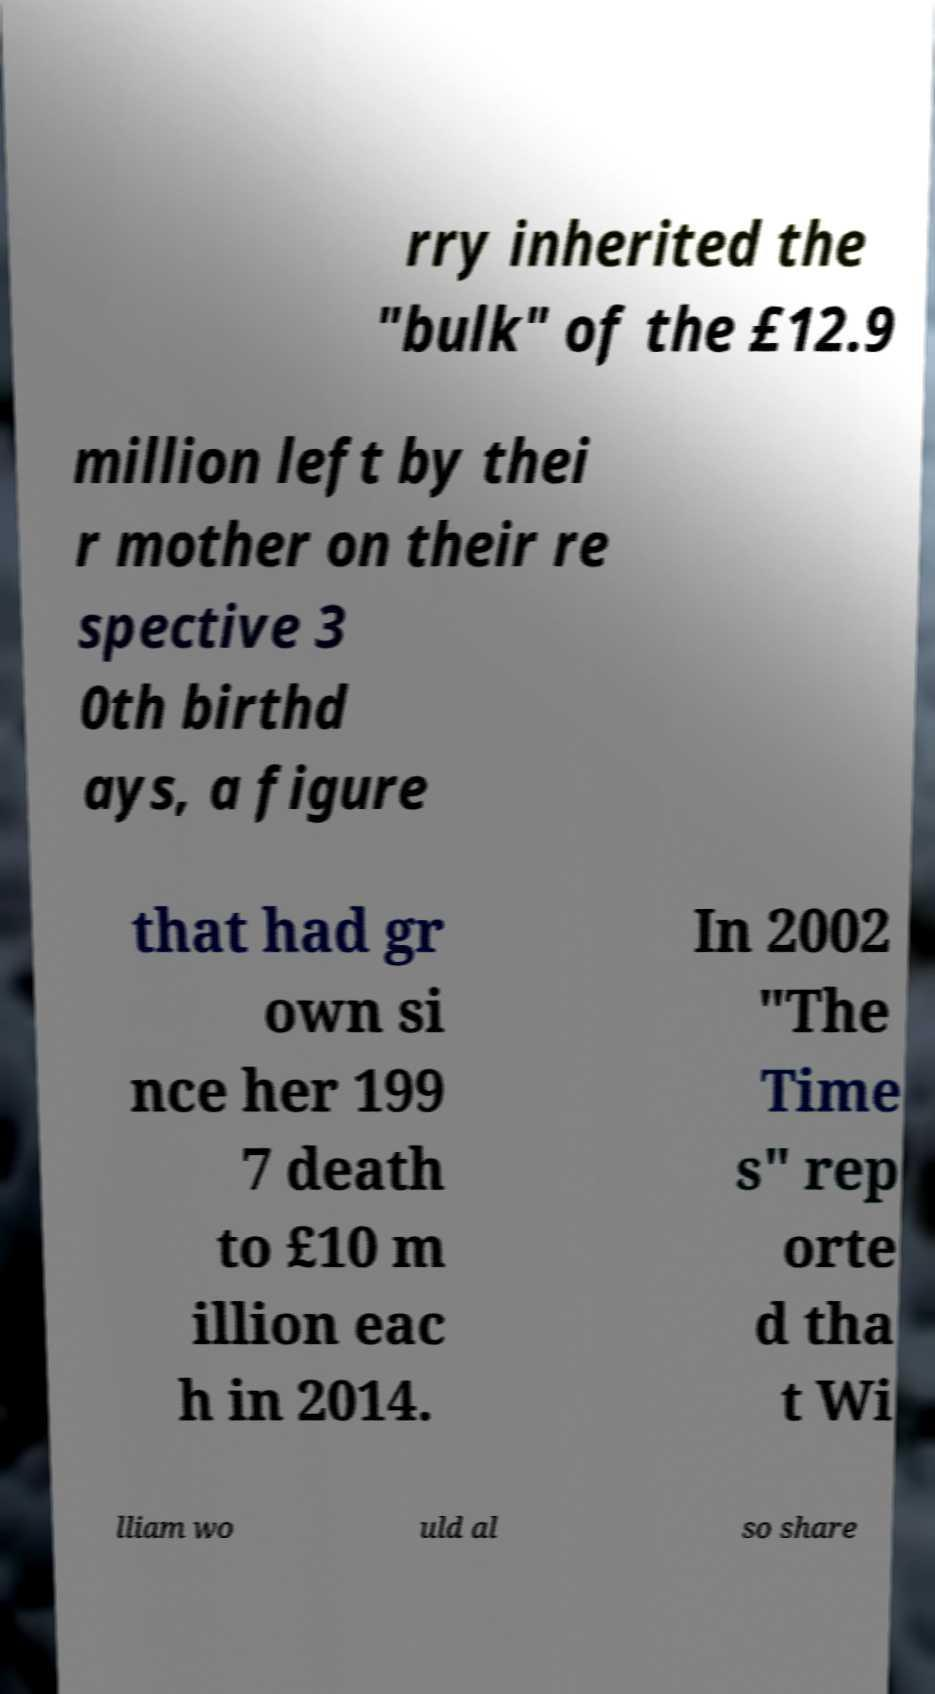Can you accurately transcribe the text from the provided image for me? rry inherited the "bulk" of the £12.9 million left by thei r mother on their re spective 3 0th birthd ays, a figure that had gr own si nce her 199 7 death to £10 m illion eac h in 2014. In 2002 "The Time s" rep orte d tha t Wi lliam wo uld al so share 